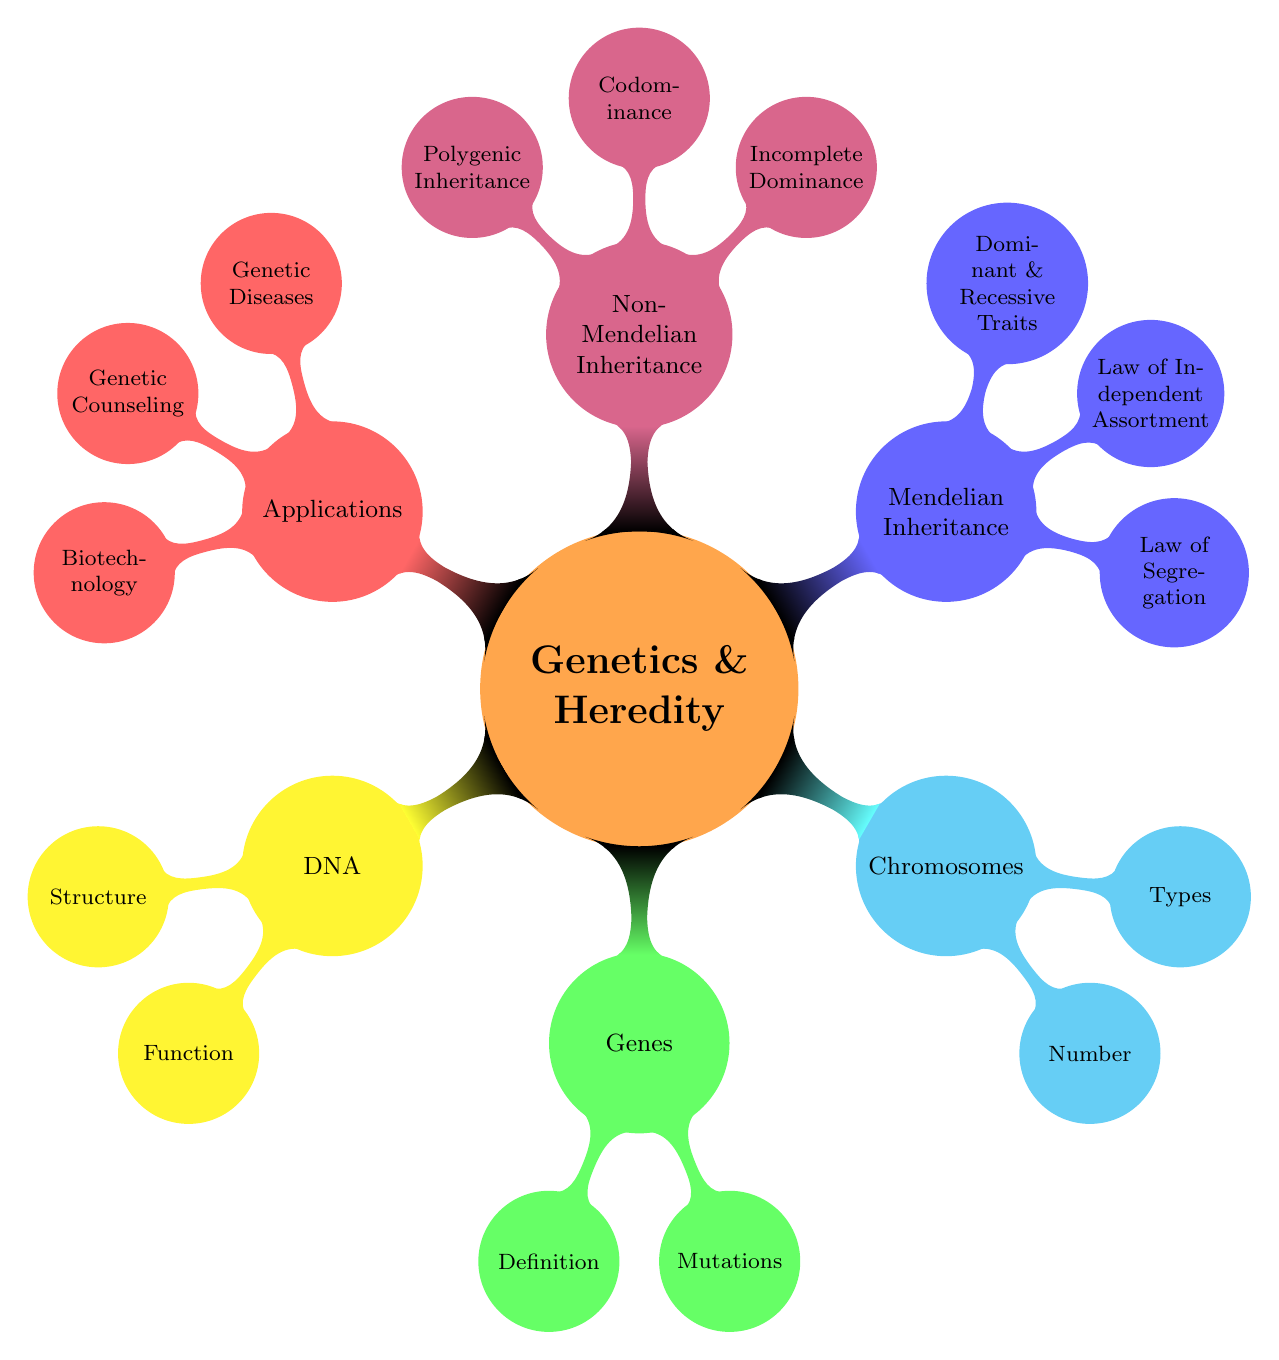What is the structure of DNA? The mind map shows that the structure of DNA is described under the DNA node. The relevant sub-node lists "Double Helix," which is a key characteristic of DNA's physical structure.
Answer: Double Helix How many chromosomes do humans have? The number of chromosomes in humans is specified in the Chromosomes section of the mind map. The sub-node directly states "46" under the Number category.
Answer: 46 What does Mendelian Inheritance include? Looking at the branch for Mendelian Inheritance, there are three main categories mentioned: "Law of Segregation," "Law of Independent Assortment," and "Dominant & Recessive Traits." These collectively describe the key concepts in Mendelian genetics.
Answer: Law of Segregation, Law of Independent Assortment, Dominant & Recessive Traits Which type of trait expression is seen in Codominance? The mind map under Non-Mendelian Inheritance shows that Codominance is characterized by "Both Traits Expressed." This explains how traits appear when both are present.
Answer: Both Traits Expressed What are two applications of genetics depicted in the mind map? The Applications section lists several applications of genetics. Two highlighted examples are "Genetic Diseases" and "Genetic Counseling." These show real-world uses of genetic information.
Answer: Genetic Diseases, Genetic Counseling How does Incomplete Dominance differ from Mendelian principles? In the Non-Mendelian Inheritance section, Incomplete Dominance is described as "Blended Traits." This indicates that it does not adhere to the classic Mendelian principles, which involve clear dominant and recessive traits.
Answer: Blended Traits What type of inheritance involves multiple genes influencing a trait? The mind map indicates under Non-Mendelian Inheritance that "Polygenic Inheritance" refers to cases where multiple genes contribute to the expression of a particular trait.
Answer: Polygenic Inheritance What is a segment of DNA that codes for proteins? The Genes section clearly states that genes are defined as "Segments of DNA" that are fundamental in the coding process for proteins.
Answer: Segments of DNA What is the main focus of genetic counseling? The Applications branch lists "Risk Assessment" and "Family Planning" under Genetic Counseling, indicating the purpose of genetic counseling is primarily focused on evaluating genetic risks and advising families.
Answer: Risk Assessment, Family Planning 